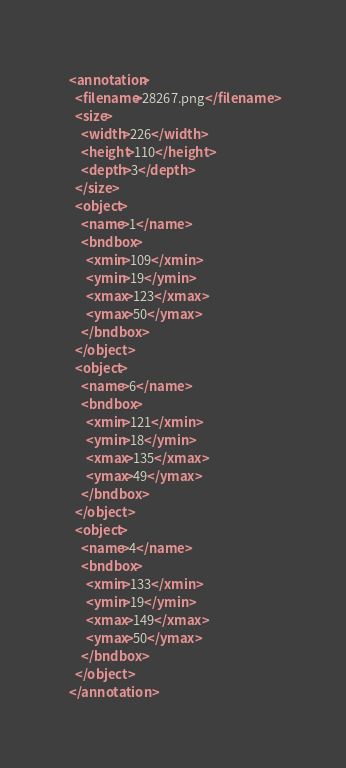<code> <loc_0><loc_0><loc_500><loc_500><_XML_><annotation>
  <filename>28267.png</filename>
  <size>
    <width>226</width>
    <height>110</height>
    <depth>3</depth>
  </size>
  <object>
    <name>1</name>
    <bndbox>
      <xmin>109</xmin>
      <ymin>19</ymin>
      <xmax>123</xmax>
      <ymax>50</ymax>
    </bndbox>
  </object>
  <object>
    <name>6</name>
    <bndbox>
      <xmin>121</xmin>
      <ymin>18</ymin>
      <xmax>135</xmax>
      <ymax>49</ymax>
    </bndbox>
  </object>
  <object>
    <name>4</name>
    <bndbox>
      <xmin>133</xmin>
      <ymin>19</ymin>
      <xmax>149</xmax>
      <ymax>50</ymax>
    </bndbox>
  </object>
</annotation>
</code> 